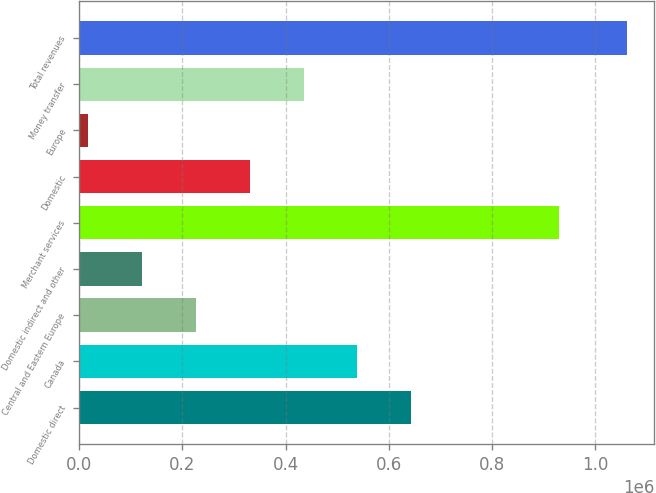Convert chart. <chart><loc_0><loc_0><loc_500><loc_500><bar_chart><fcel>Domestic direct<fcel>Canada<fcel>Central and Eastern Europe<fcel>Domestic indirect and other<fcel>Merchant services<fcel>Domestic<fcel>Europe<fcel>Money transfer<fcel>Total revenues<nl><fcel>643700<fcel>539244<fcel>225877<fcel>121421<fcel>929142<fcel>330332<fcel>16965<fcel>434788<fcel>1.06152e+06<nl></chart> 